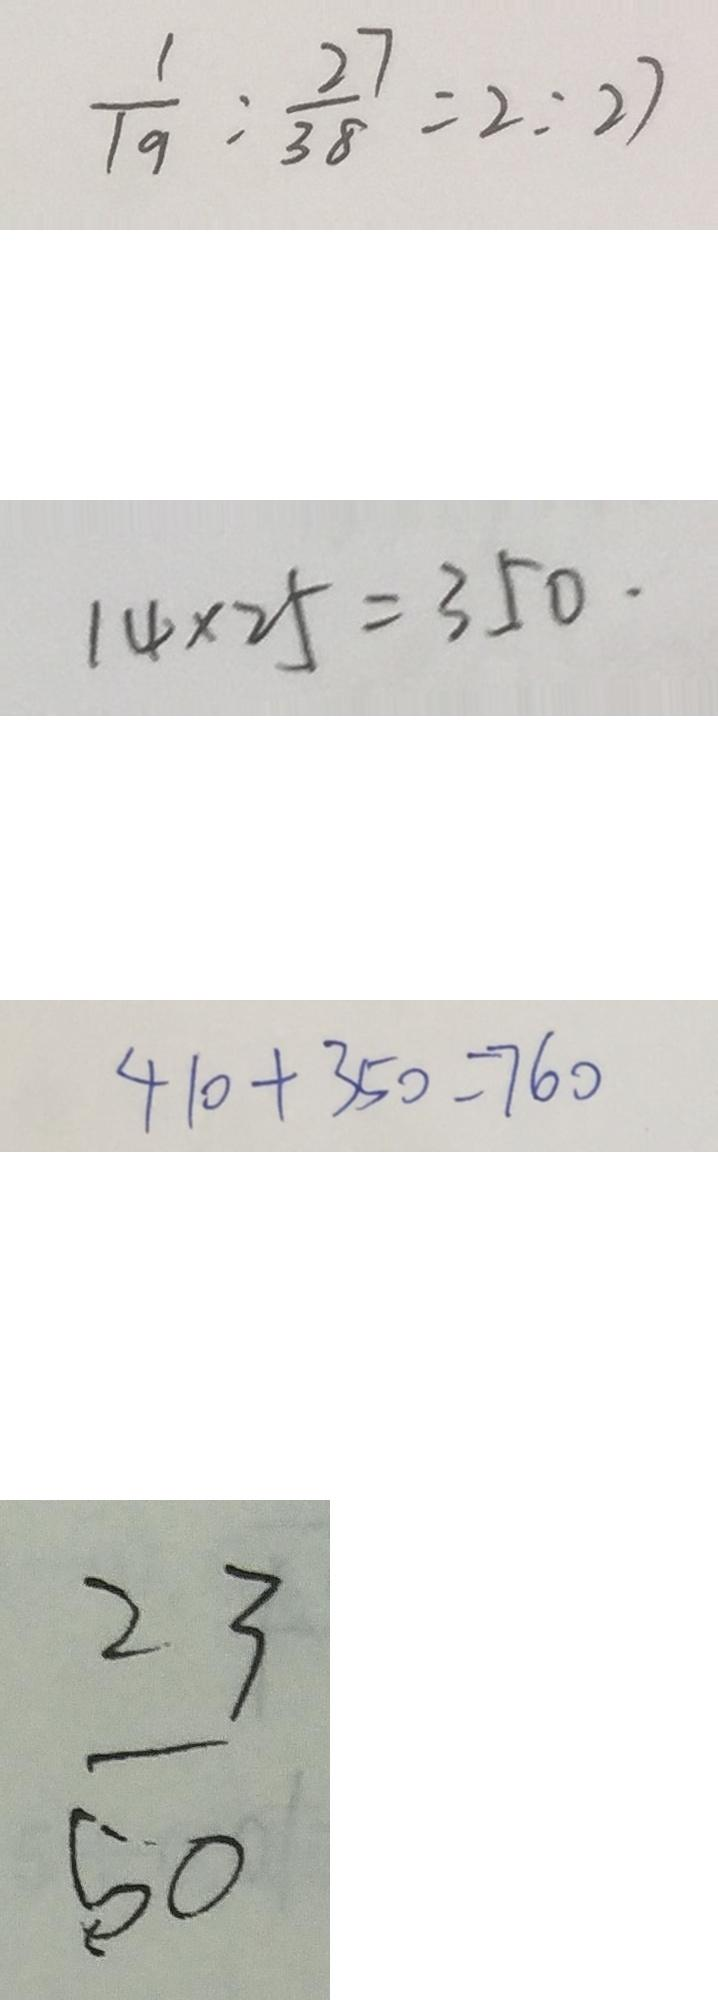Convert formula to latex. <formula><loc_0><loc_0><loc_500><loc_500>\frac { 1 } { 1 9 } : \frac { 2 7 } { 3 8 } = 2 : 2 7 
 1 4 \times 2 5 = 3 5 0 . 
 4 1 0 + 3 5 0 = 7 6 0 
 \frac { 2 3 } { 5 0 }</formula> 